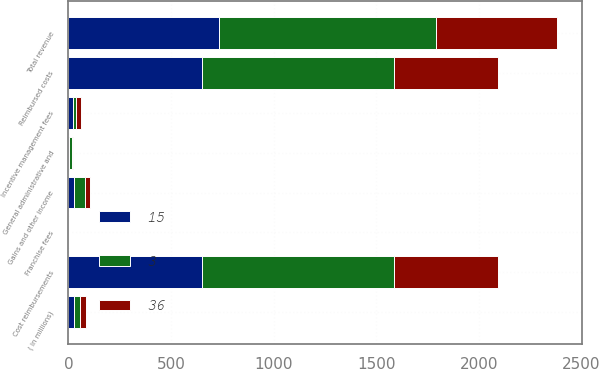<chart> <loc_0><loc_0><loc_500><loc_500><stacked_bar_chart><ecel><fcel>( in millions)<fcel>Franchise fees<fcel>Incentive management fees<fcel>Cost reimbursements<fcel>Total revenue<fcel>General administrative and<fcel>Reimbursed costs<fcel>Gains and other income<nl><fcel>36<fcel>28<fcel>1<fcel>26<fcel>510<fcel>593<fcel>4<fcel>510<fcel>25<nl><fcel>15<fcel>28<fcel>2<fcel>22<fcel>649<fcel>735<fcel>1<fcel>649<fcel>28<nl><fcel>3<fcel>28<fcel>2<fcel>14<fcel>936<fcel>1054<fcel>19<fcel>936<fcel>54<nl></chart> 